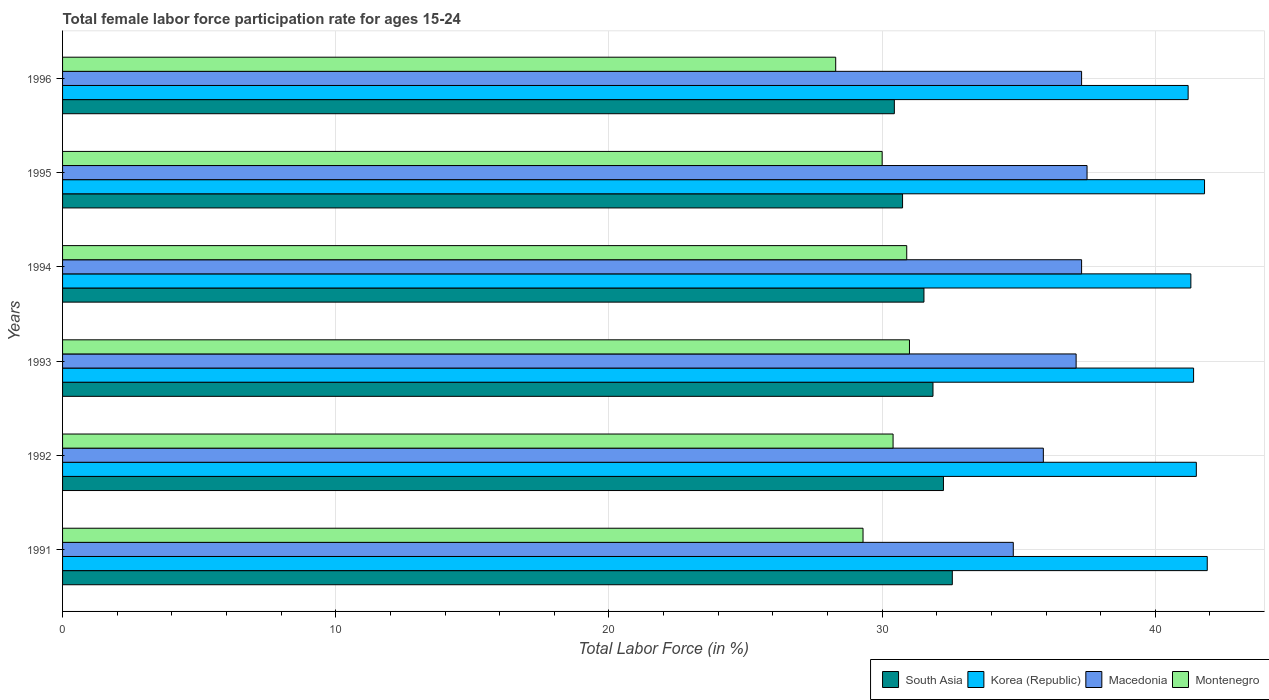How many groups of bars are there?
Offer a very short reply. 6. How many bars are there on the 5th tick from the bottom?
Your answer should be very brief. 4. In how many cases, is the number of bars for a given year not equal to the number of legend labels?
Your answer should be compact. 0. What is the female labor force participation rate in South Asia in 1993?
Give a very brief answer. 31.86. Across all years, what is the maximum female labor force participation rate in Montenegro?
Provide a short and direct response. 31. Across all years, what is the minimum female labor force participation rate in South Asia?
Make the answer very short. 30.45. In which year was the female labor force participation rate in Korea (Republic) maximum?
Make the answer very short. 1991. What is the total female labor force participation rate in South Asia in the graph?
Your response must be concise. 189.4. What is the difference between the female labor force participation rate in South Asia in 1994 and that in 1995?
Your answer should be very brief. 0.78. What is the difference between the female labor force participation rate in Korea (Republic) in 1996 and the female labor force participation rate in Montenegro in 1991?
Give a very brief answer. 11.9. What is the average female labor force participation rate in Macedonia per year?
Your response must be concise. 36.65. In the year 1994, what is the difference between the female labor force participation rate in Montenegro and female labor force participation rate in South Asia?
Your response must be concise. -0.63. What is the ratio of the female labor force participation rate in Macedonia in 1992 to that in 1996?
Ensure brevity in your answer.  0.96. Is the difference between the female labor force participation rate in Montenegro in 1995 and 1996 greater than the difference between the female labor force participation rate in South Asia in 1995 and 1996?
Give a very brief answer. Yes. What is the difference between the highest and the second highest female labor force participation rate in Montenegro?
Make the answer very short. 0.1. What is the difference between the highest and the lowest female labor force participation rate in Korea (Republic)?
Make the answer very short. 0.7. Is it the case that in every year, the sum of the female labor force participation rate in Macedonia and female labor force participation rate in Korea (Republic) is greater than the sum of female labor force participation rate in Montenegro and female labor force participation rate in South Asia?
Your response must be concise. Yes. What does the 1st bar from the top in 1996 represents?
Your answer should be compact. Montenegro. What does the 4th bar from the bottom in 1995 represents?
Your answer should be compact. Montenegro. How many years are there in the graph?
Your response must be concise. 6. What is the difference between two consecutive major ticks on the X-axis?
Provide a short and direct response. 10. Does the graph contain any zero values?
Offer a very short reply. No. Does the graph contain grids?
Your answer should be very brief. Yes. Where does the legend appear in the graph?
Offer a very short reply. Bottom right. How are the legend labels stacked?
Provide a short and direct response. Horizontal. What is the title of the graph?
Offer a very short reply. Total female labor force participation rate for ages 15-24. What is the label or title of the X-axis?
Your answer should be very brief. Total Labor Force (in %). What is the label or title of the Y-axis?
Provide a succinct answer. Years. What is the Total Labor Force (in %) of South Asia in 1991?
Make the answer very short. 32.57. What is the Total Labor Force (in %) in Korea (Republic) in 1991?
Your response must be concise. 41.9. What is the Total Labor Force (in %) in Macedonia in 1991?
Provide a short and direct response. 34.8. What is the Total Labor Force (in %) in Montenegro in 1991?
Offer a very short reply. 29.3. What is the Total Labor Force (in %) of South Asia in 1992?
Offer a terse response. 32.24. What is the Total Labor Force (in %) in Korea (Republic) in 1992?
Give a very brief answer. 41.5. What is the Total Labor Force (in %) in Macedonia in 1992?
Ensure brevity in your answer.  35.9. What is the Total Labor Force (in %) in Montenegro in 1992?
Your answer should be very brief. 30.4. What is the Total Labor Force (in %) of South Asia in 1993?
Offer a terse response. 31.86. What is the Total Labor Force (in %) in Korea (Republic) in 1993?
Your answer should be compact. 41.4. What is the Total Labor Force (in %) of Macedonia in 1993?
Offer a terse response. 37.1. What is the Total Labor Force (in %) of Montenegro in 1993?
Offer a terse response. 31. What is the Total Labor Force (in %) in South Asia in 1994?
Your answer should be very brief. 31.53. What is the Total Labor Force (in %) in Korea (Republic) in 1994?
Give a very brief answer. 41.3. What is the Total Labor Force (in %) in Macedonia in 1994?
Offer a very short reply. 37.3. What is the Total Labor Force (in %) of Montenegro in 1994?
Offer a terse response. 30.9. What is the Total Labor Force (in %) of South Asia in 1995?
Offer a terse response. 30.75. What is the Total Labor Force (in %) of Korea (Republic) in 1995?
Offer a terse response. 41.8. What is the Total Labor Force (in %) in Macedonia in 1995?
Provide a short and direct response. 37.5. What is the Total Labor Force (in %) in South Asia in 1996?
Give a very brief answer. 30.45. What is the Total Labor Force (in %) in Korea (Republic) in 1996?
Make the answer very short. 41.2. What is the Total Labor Force (in %) in Macedonia in 1996?
Your answer should be very brief. 37.3. What is the Total Labor Force (in %) of Montenegro in 1996?
Provide a short and direct response. 28.3. Across all years, what is the maximum Total Labor Force (in %) of South Asia?
Your response must be concise. 32.57. Across all years, what is the maximum Total Labor Force (in %) in Korea (Republic)?
Make the answer very short. 41.9. Across all years, what is the maximum Total Labor Force (in %) of Macedonia?
Provide a short and direct response. 37.5. Across all years, what is the maximum Total Labor Force (in %) in Montenegro?
Offer a very short reply. 31. Across all years, what is the minimum Total Labor Force (in %) of South Asia?
Your response must be concise. 30.45. Across all years, what is the minimum Total Labor Force (in %) of Korea (Republic)?
Offer a terse response. 41.2. Across all years, what is the minimum Total Labor Force (in %) of Macedonia?
Offer a very short reply. 34.8. Across all years, what is the minimum Total Labor Force (in %) in Montenegro?
Your answer should be compact. 28.3. What is the total Total Labor Force (in %) in South Asia in the graph?
Your answer should be compact. 189.4. What is the total Total Labor Force (in %) of Korea (Republic) in the graph?
Your answer should be very brief. 249.1. What is the total Total Labor Force (in %) in Macedonia in the graph?
Provide a short and direct response. 219.9. What is the total Total Labor Force (in %) of Montenegro in the graph?
Give a very brief answer. 179.9. What is the difference between the Total Labor Force (in %) in South Asia in 1991 and that in 1992?
Your response must be concise. 0.32. What is the difference between the Total Labor Force (in %) in Korea (Republic) in 1991 and that in 1992?
Ensure brevity in your answer.  0.4. What is the difference between the Total Labor Force (in %) in South Asia in 1991 and that in 1993?
Offer a very short reply. 0.71. What is the difference between the Total Labor Force (in %) in South Asia in 1991 and that in 1994?
Offer a very short reply. 1.04. What is the difference between the Total Labor Force (in %) in Macedonia in 1991 and that in 1994?
Keep it short and to the point. -2.5. What is the difference between the Total Labor Force (in %) of South Asia in 1991 and that in 1995?
Your response must be concise. 1.82. What is the difference between the Total Labor Force (in %) in Korea (Republic) in 1991 and that in 1995?
Your response must be concise. 0.1. What is the difference between the Total Labor Force (in %) of Macedonia in 1991 and that in 1995?
Your answer should be very brief. -2.7. What is the difference between the Total Labor Force (in %) of Montenegro in 1991 and that in 1995?
Give a very brief answer. -0.7. What is the difference between the Total Labor Force (in %) in South Asia in 1991 and that in 1996?
Provide a succinct answer. 2.12. What is the difference between the Total Labor Force (in %) of Korea (Republic) in 1991 and that in 1996?
Your answer should be compact. 0.7. What is the difference between the Total Labor Force (in %) of Montenegro in 1991 and that in 1996?
Provide a short and direct response. 1. What is the difference between the Total Labor Force (in %) of South Asia in 1992 and that in 1993?
Your answer should be compact. 0.38. What is the difference between the Total Labor Force (in %) of Korea (Republic) in 1992 and that in 1993?
Provide a succinct answer. 0.1. What is the difference between the Total Labor Force (in %) of Montenegro in 1992 and that in 1993?
Make the answer very short. -0.6. What is the difference between the Total Labor Force (in %) of South Asia in 1992 and that in 1994?
Your response must be concise. 0.71. What is the difference between the Total Labor Force (in %) in Macedonia in 1992 and that in 1994?
Offer a terse response. -1.4. What is the difference between the Total Labor Force (in %) of Montenegro in 1992 and that in 1994?
Ensure brevity in your answer.  -0.5. What is the difference between the Total Labor Force (in %) of South Asia in 1992 and that in 1995?
Your response must be concise. 1.5. What is the difference between the Total Labor Force (in %) in Korea (Republic) in 1992 and that in 1995?
Your response must be concise. -0.3. What is the difference between the Total Labor Force (in %) of Montenegro in 1992 and that in 1995?
Make the answer very short. 0.4. What is the difference between the Total Labor Force (in %) in South Asia in 1992 and that in 1996?
Provide a succinct answer. 1.8. What is the difference between the Total Labor Force (in %) in Macedonia in 1992 and that in 1996?
Your response must be concise. -1.4. What is the difference between the Total Labor Force (in %) of South Asia in 1993 and that in 1994?
Your response must be concise. 0.33. What is the difference between the Total Labor Force (in %) in Macedonia in 1993 and that in 1994?
Keep it short and to the point. -0.2. What is the difference between the Total Labor Force (in %) of Montenegro in 1993 and that in 1994?
Give a very brief answer. 0.1. What is the difference between the Total Labor Force (in %) of South Asia in 1993 and that in 1995?
Provide a short and direct response. 1.11. What is the difference between the Total Labor Force (in %) of Korea (Republic) in 1993 and that in 1995?
Make the answer very short. -0.4. What is the difference between the Total Labor Force (in %) in Montenegro in 1993 and that in 1995?
Your answer should be compact. 1. What is the difference between the Total Labor Force (in %) of South Asia in 1993 and that in 1996?
Keep it short and to the point. 1.41. What is the difference between the Total Labor Force (in %) of South Asia in 1994 and that in 1995?
Your response must be concise. 0.78. What is the difference between the Total Labor Force (in %) of Korea (Republic) in 1994 and that in 1995?
Offer a terse response. -0.5. What is the difference between the Total Labor Force (in %) of Montenegro in 1994 and that in 1995?
Your response must be concise. 0.9. What is the difference between the Total Labor Force (in %) of South Asia in 1994 and that in 1996?
Your response must be concise. 1.08. What is the difference between the Total Labor Force (in %) of Macedonia in 1994 and that in 1996?
Your answer should be compact. 0. What is the difference between the Total Labor Force (in %) of South Asia in 1995 and that in 1996?
Your answer should be very brief. 0.3. What is the difference between the Total Labor Force (in %) in Korea (Republic) in 1995 and that in 1996?
Your response must be concise. 0.6. What is the difference between the Total Labor Force (in %) of Macedonia in 1995 and that in 1996?
Keep it short and to the point. 0.2. What is the difference between the Total Labor Force (in %) of Montenegro in 1995 and that in 1996?
Ensure brevity in your answer.  1.7. What is the difference between the Total Labor Force (in %) of South Asia in 1991 and the Total Labor Force (in %) of Korea (Republic) in 1992?
Keep it short and to the point. -8.93. What is the difference between the Total Labor Force (in %) in South Asia in 1991 and the Total Labor Force (in %) in Macedonia in 1992?
Offer a very short reply. -3.33. What is the difference between the Total Labor Force (in %) in South Asia in 1991 and the Total Labor Force (in %) in Montenegro in 1992?
Offer a very short reply. 2.17. What is the difference between the Total Labor Force (in %) in Korea (Republic) in 1991 and the Total Labor Force (in %) in Macedonia in 1992?
Offer a very short reply. 6. What is the difference between the Total Labor Force (in %) of Korea (Republic) in 1991 and the Total Labor Force (in %) of Montenegro in 1992?
Offer a terse response. 11.5. What is the difference between the Total Labor Force (in %) in Macedonia in 1991 and the Total Labor Force (in %) in Montenegro in 1992?
Ensure brevity in your answer.  4.4. What is the difference between the Total Labor Force (in %) of South Asia in 1991 and the Total Labor Force (in %) of Korea (Republic) in 1993?
Your answer should be compact. -8.83. What is the difference between the Total Labor Force (in %) in South Asia in 1991 and the Total Labor Force (in %) in Macedonia in 1993?
Your answer should be very brief. -4.53. What is the difference between the Total Labor Force (in %) in South Asia in 1991 and the Total Labor Force (in %) in Montenegro in 1993?
Make the answer very short. 1.57. What is the difference between the Total Labor Force (in %) of Korea (Republic) in 1991 and the Total Labor Force (in %) of Macedonia in 1993?
Provide a short and direct response. 4.8. What is the difference between the Total Labor Force (in %) in Korea (Republic) in 1991 and the Total Labor Force (in %) in Montenegro in 1993?
Ensure brevity in your answer.  10.9. What is the difference between the Total Labor Force (in %) in South Asia in 1991 and the Total Labor Force (in %) in Korea (Republic) in 1994?
Your answer should be compact. -8.73. What is the difference between the Total Labor Force (in %) of South Asia in 1991 and the Total Labor Force (in %) of Macedonia in 1994?
Provide a short and direct response. -4.73. What is the difference between the Total Labor Force (in %) in South Asia in 1991 and the Total Labor Force (in %) in Montenegro in 1994?
Provide a short and direct response. 1.67. What is the difference between the Total Labor Force (in %) in Korea (Republic) in 1991 and the Total Labor Force (in %) in Macedonia in 1994?
Give a very brief answer. 4.6. What is the difference between the Total Labor Force (in %) of South Asia in 1991 and the Total Labor Force (in %) of Korea (Republic) in 1995?
Give a very brief answer. -9.23. What is the difference between the Total Labor Force (in %) in South Asia in 1991 and the Total Labor Force (in %) in Macedonia in 1995?
Ensure brevity in your answer.  -4.93. What is the difference between the Total Labor Force (in %) of South Asia in 1991 and the Total Labor Force (in %) of Montenegro in 1995?
Provide a short and direct response. 2.57. What is the difference between the Total Labor Force (in %) of South Asia in 1991 and the Total Labor Force (in %) of Korea (Republic) in 1996?
Keep it short and to the point. -8.63. What is the difference between the Total Labor Force (in %) in South Asia in 1991 and the Total Labor Force (in %) in Macedonia in 1996?
Your answer should be very brief. -4.73. What is the difference between the Total Labor Force (in %) of South Asia in 1991 and the Total Labor Force (in %) of Montenegro in 1996?
Ensure brevity in your answer.  4.27. What is the difference between the Total Labor Force (in %) of Korea (Republic) in 1991 and the Total Labor Force (in %) of Macedonia in 1996?
Offer a terse response. 4.6. What is the difference between the Total Labor Force (in %) of Macedonia in 1991 and the Total Labor Force (in %) of Montenegro in 1996?
Provide a succinct answer. 6.5. What is the difference between the Total Labor Force (in %) in South Asia in 1992 and the Total Labor Force (in %) in Korea (Republic) in 1993?
Make the answer very short. -9.16. What is the difference between the Total Labor Force (in %) in South Asia in 1992 and the Total Labor Force (in %) in Macedonia in 1993?
Ensure brevity in your answer.  -4.86. What is the difference between the Total Labor Force (in %) of South Asia in 1992 and the Total Labor Force (in %) of Montenegro in 1993?
Your answer should be very brief. 1.24. What is the difference between the Total Labor Force (in %) in Korea (Republic) in 1992 and the Total Labor Force (in %) in Montenegro in 1993?
Make the answer very short. 10.5. What is the difference between the Total Labor Force (in %) of South Asia in 1992 and the Total Labor Force (in %) of Korea (Republic) in 1994?
Make the answer very short. -9.06. What is the difference between the Total Labor Force (in %) in South Asia in 1992 and the Total Labor Force (in %) in Macedonia in 1994?
Ensure brevity in your answer.  -5.06. What is the difference between the Total Labor Force (in %) of South Asia in 1992 and the Total Labor Force (in %) of Montenegro in 1994?
Offer a very short reply. 1.34. What is the difference between the Total Labor Force (in %) in Korea (Republic) in 1992 and the Total Labor Force (in %) in Macedonia in 1994?
Make the answer very short. 4.2. What is the difference between the Total Labor Force (in %) of South Asia in 1992 and the Total Labor Force (in %) of Korea (Republic) in 1995?
Keep it short and to the point. -9.56. What is the difference between the Total Labor Force (in %) of South Asia in 1992 and the Total Labor Force (in %) of Macedonia in 1995?
Keep it short and to the point. -5.26. What is the difference between the Total Labor Force (in %) in South Asia in 1992 and the Total Labor Force (in %) in Montenegro in 1995?
Provide a short and direct response. 2.24. What is the difference between the Total Labor Force (in %) of Macedonia in 1992 and the Total Labor Force (in %) of Montenegro in 1995?
Provide a short and direct response. 5.9. What is the difference between the Total Labor Force (in %) of South Asia in 1992 and the Total Labor Force (in %) of Korea (Republic) in 1996?
Keep it short and to the point. -8.96. What is the difference between the Total Labor Force (in %) in South Asia in 1992 and the Total Labor Force (in %) in Macedonia in 1996?
Offer a terse response. -5.06. What is the difference between the Total Labor Force (in %) of South Asia in 1992 and the Total Labor Force (in %) of Montenegro in 1996?
Keep it short and to the point. 3.94. What is the difference between the Total Labor Force (in %) in Korea (Republic) in 1992 and the Total Labor Force (in %) in Montenegro in 1996?
Your response must be concise. 13.2. What is the difference between the Total Labor Force (in %) in Macedonia in 1992 and the Total Labor Force (in %) in Montenegro in 1996?
Your answer should be compact. 7.6. What is the difference between the Total Labor Force (in %) in South Asia in 1993 and the Total Labor Force (in %) in Korea (Republic) in 1994?
Ensure brevity in your answer.  -9.44. What is the difference between the Total Labor Force (in %) in South Asia in 1993 and the Total Labor Force (in %) in Macedonia in 1994?
Give a very brief answer. -5.44. What is the difference between the Total Labor Force (in %) of South Asia in 1993 and the Total Labor Force (in %) of Montenegro in 1994?
Offer a very short reply. 0.96. What is the difference between the Total Labor Force (in %) in Korea (Republic) in 1993 and the Total Labor Force (in %) in Macedonia in 1994?
Ensure brevity in your answer.  4.1. What is the difference between the Total Labor Force (in %) of Korea (Republic) in 1993 and the Total Labor Force (in %) of Montenegro in 1994?
Your answer should be very brief. 10.5. What is the difference between the Total Labor Force (in %) of South Asia in 1993 and the Total Labor Force (in %) of Korea (Republic) in 1995?
Keep it short and to the point. -9.94. What is the difference between the Total Labor Force (in %) in South Asia in 1993 and the Total Labor Force (in %) in Macedonia in 1995?
Ensure brevity in your answer.  -5.64. What is the difference between the Total Labor Force (in %) of South Asia in 1993 and the Total Labor Force (in %) of Montenegro in 1995?
Give a very brief answer. 1.86. What is the difference between the Total Labor Force (in %) of Korea (Republic) in 1993 and the Total Labor Force (in %) of Macedonia in 1995?
Give a very brief answer. 3.9. What is the difference between the Total Labor Force (in %) of Korea (Republic) in 1993 and the Total Labor Force (in %) of Montenegro in 1995?
Give a very brief answer. 11.4. What is the difference between the Total Labor Force (in %) of South Asia in 1993 and the Total Labor Force (in %) of Korea (Republic) in 1996?
Keep it short and to the point. -9.34. What is the difference between the Total Labor Force (in %) of South Asia in 1993 and the Total Labor Force (in %) of Macedonia in 1996?
Provide a succinct answer. -5.44. What is the difference between the Total Labor Force (in %) in South Asia in 1993 and the Total Labor Force (in %) in Montenegro in 1996?
Offer a very short reply. 3.56. What is the difference between the Total Labor Force (in %) in Korea (Republic) in 1993 and the Total Labor Force (in %) in Montenegro in 1996?
Your answer should be compact. 13.1. What is the difference between the Total Labor Force (in %) in Macedonia in 1993 and the Total Labor Force (in %) in Montenegro in 1996?
Keep it short and to the point. 8.8. What is the difference between the Total Labor Force (in %) of South Asia in 1994 and the Total Labor Force (in %) of Korea (Republic) in 1995?
Ensure brevity in your answer.  -10.27. What is the difference between the Total Labor Force (in %) of South Asia in 1994 and the Total Labor Force (in %) of Macedonia in 1995?
Your answer should be compact. -5.97. What is the difference between the Total Labor Force (in %) in South Asia in 1994 and the Total Labor Force (in %) in Montenegro in 1995?
Make the answer very short. 1.53. What is the difference between the Total Labor Force (in %) of Korea (Republic) in 1994 and the Total Labor Force (in %) of Macedonia in 1995?
Provide a short and direct response. 3.8. What is the difference between the Total Labor Force (in %) in South Asia in 1994 and the Total Labor Force (in %) in Korea (Republic) in 1996?
Offer a terse response. -9.67. What is the difference between the Total Labor Force (in %) of South Asia in 1994 and the Total Labor Force (in %) of Macedonia in 1996?
Give a very brief answer. -5.77. What is the difference between the Total Labor Force (in %) in South Asia in 1994 and the Total Labor Force (in %) in Montenegro in 1996?
Ensure brevity in your answer.  3.23. What is the difference between the Total Labor Force (in %) of South Asia in 1995 and the Total Labor Force (in %) of Korea (Republic) in 1996?
Ensure brevity in your answer.  -10.45. What is the difference between the Total Labor Force (in %) in South Asia in 1995 and the Total Labor Force (in %) in Macedonia in 1996?
Offer a terse response. -6.55. What is the difference between the Total Labor Force (in %) in South Asia in 1995 and the Total Labor Force (in %) in Montenegro in 1996?
Offer a very short reply. 2.45. What is the difference between the Total Labor Force (in %) of Korea (Republic) in 1995 and the Total Labor Force (in %) of Macedonia in 1996?
Make the answer very short. 4.5. What is the difference between the Total Labor Force (in %) of Macedonia in 1995 and the Total Labor Force (in %) of Montenegro in 1996?
Keep it short and to the point. 9.2. What is the average Total Labor Force (in %) of South Asia per year?
Give a very brief answer. 31.57. What is the average Total Labor Force (in %) of Korea (Republic) per year?
Ensure brevity in your answer.  41.52. What is the average Total Labor Force (in %) in Macedonia per year?
Your answer should be compact. 36.65. What is the average Total Labor Force (in %) in Montenegro per year?
Make the answer very short. 29.98. In the year 1991, what is the difference between the Total Labor Force (in %) in South Asia and Total Labor Force (in %) in Korea (Republic)?
Provide a succinct answer. -9.33. In the year 1991, what is the difference between the Total Labor Force (in %) in South Asia and Total Labor Force (in %) in Macedonia?
Give a very brief answer. -2.23. In the year 1991, what is the difference between the Total Labor Force (in %) in South Asia and Total Labor Force (in %) in Montenegro?
Your response must be concise. 3.27. In the year 1991, what is the difference between the Total Labor Force (in %) in Korea (Republic) and Total Labor Force (in %) in Montenegro?
Keep it short and to the point. 12.6. In the year 1992, what is the difference between the Total Labor Force (in %) in South Asia and Total Labor Force (in %) in Korea (Republic)?
Make the answer very short. -9.26. In the year 1992, what is the difference between the Total Labor Force (in %) in South Asia and Total Labor Force (in %) in Macedonia?
Your response must be concise. -3.66. In the year 1992, what is the difference between the Total Labor Force (in %) in South Asia and Total Labor Force (in %) in Montenegro?
Keep it short and to the point. 1.84. In the year 1993, what is the difference between the Total Labor Force (in %) in South Asia and Total Labor Force (in %) in Korea (Republic)?
Keep it short and to the point. -9.54. In the year 1993, what is the difference between the Total Labor Force (in %) of South Asia and Total Labor Force (in %) of Macedonia?
Offer a very short reply. -5.24. In the year 1993, what is the difference between the Total Labor Force (in %) of South Asia and Total Labor Force (in %) of Montenegro?
Make the answer very short. 0.86. In the year 1993, what is the difference between the Total Labor Force (in %) in Korea (Republic) and Total Labor Force (in %) in Macedonia?
Provide a succinct answer. 4.3. In the year 1993, what is the difference between the Total Labor Force (in %) in Korea (Republic) and Total Labor Force (in %) in Montenegro?
Provide a short and direct response. 10.4. In the year 1993, what is the difference between the Total Labor Force (in %) in Macedonia and Total Labor Force (in %) in Montenegro?
Your answer should be compact. 6.1. In the year 1994, what is the difference between the Total Labor Force (in %) of South Asia and Total Labor Force (in %) of Korea (Republic)?
Provide a succinct answer. -9.77. In the year 1994, what is the difference between the Total Labor Force (in %) of South Asia and Total Labor Force (in %) of Macedonia?
Ensure brevity in your answer.  -5.77. In the year 1994, what is the difference between the Total Labor Force (in %) of South Asia and Total Labor Force (in %) of Montenegro?
Ensure brevity in your answer.  0.63. In the year 1994, what is the difference between the Total Labor Force (in %) of Korea (Republic) and Total Labor Force (in %) of Montenegro?
Your answer should be compact. 10.4. In the year 1995, what is the difference between the Total Labor Force (in %) in South Asia and Total Labor Force (in %) in Korea (Republic)?
Offer a terse response. -11.05. In the year 1995, what is the difference between the Total Labor Force (in %) of South Asia and Total Labor Force (in %) of Macedonia?
Make the answer very short. -6.75. In the year 1995, what is the difference between the Total Labor Force (in %) of South Asia and Total Labor Force (in %) of Montenegro?
Your answer should be very brief. 0.75. In the year 1995, what is the difference between the Total Labor Force (in %) of Korea (Republic) and Total Labor Force (in %) of Montenegro?
Your answer should be very brief. 11.8. In the year 1995, what is the difference between the Total Labor Force (in %) in Macedonia and Total Labor Force (in %) in Montenegro?
Provide a succinct answer. 7.5. In the year 1996, what is the difference between the Total Labor Force (in %) in South Asia and Total Labor Force (in %) in Korea (Republic)?
Offer a very short reply. -10.75. In the year 1996, what is the difference between the Total Labor Force (in %) of South Asia and Total Labor Force (in %) of Macedonia?
Your answer should be compact. -6.85. In the year 1996, what is the difference between the Total Labor Force (in %) in South Asia and Total Labor Force (in %) in Montenegro?
Offer a very short reply. 2.15. In the year 1996, what is the difference between the Total Labor Force (in %) in Korea (Republic) and Total Labor Force (in %) in Macedonia?
Provide a short and direct response. 3.9. What is the ratio of the Total Labor Force (in %) in Korea (Republic) in 1991 to that in 1992?
Offer a very short reply. 1.01. What is the ratio of the Total Labor Force (in %) in Macedonia in 1991 to that in 1992?
Offer a terse response. 0.97. What is the ratio of the Total Labor Force (in %) in Montenegro in 1991 to that in 1992?
Provide a succinct answer. 0.96. What is the ratio of the Total Labor Force (in %) of South Asia in 1991 to that in 1993?
Your response must be concise. 1.02. What is the ratio of the Total Labor Force (in %) of Korea (Republic) in 1991 to that in 1993?
Your answer should be compact. 1.01. What is the ratio of the Total Labor Force (in %) of Macedonia in 1991 to that in 1993?
Make the answer very short. 0.94. What is the ratio of the Total Labor Force (in %) of Montenegro in 1991 to that in 1993?
Keep it short and to the point. 0.95. What is the ratio of the Total Labor Force (in %) in South Asia in 1991 to that in 1994?
Make the answer very short. 1.03. What is the ratio of the Total Labor Force (in %) of Korea (Republic) in 1991 to that in 1994?
Keep it short and to the point. 1.01. What is the ratio of the Total Labor Force (in %) of Macedonia in 1991 to that in 1994?
Offer a very short reply. 0.93. What is the ratio of the Total Labor Force (in %) of Montenegro in 1991 to that in 1994?
Provide a short and direct response. 0.95. What is the ratio of the Total Labor Force (in %) of South Asia in 1991 to that in 1995?
Keep it short and to the point. 1.06. What is the ratio of the Total Labor Force (in %) in Macedonia in 1991 to that in 1995?
Offer a terse response. 0.93. What is the ratio of the Total Labor Force (in %) in Montenegro in 1991 to that in 1995?
Ensure brevity in your answer.  0.98. What is the ratio of the Total Labor Force (in %) in South Asia in 1991 to that in 1996?
Your answer should be very brief. 1.07. What is the ratio of the Total Labor Force (in %) of Macedonia in 1991 to that in 1996?
Your answer should be compact. 0.93. What is the ratio of the Total Labor Force (in %) of Montenegro in 1991 to that in 1996?
Your answer should be very brief. 1.04. What is the ratio of the Total Labor Force (in %) in South Asia in 1992 to that in 1993?
Your answer should be very brief. 1.01. What is the ratio of the Total Labor Force (in %) in Montenegro in 1992 to that in 1993?
Ensure brevity in your answer.  0.98. What is the ratio of the Total Labor Force (in %) in South Asia in 1992 to that in 1994?
Provide a succinct answer. 1.02. What is the ratio of the Total Labor Force (in %) of Korea (Republic) in 1992 to that in 1994?
Keep it short and to the point. 1. What is the ratio of the Total Labor Force (in %) of Macedonia in 1992 to that in 1994?
Make the answer very short. 0.96. What is the ratio of the Total Labor Force (in %) in Montenegro in 1992 to that in 1994?
Keep it short and to the point. 0.98. What is the ratio of the Total Labor Force (in %) in South Asia in 1992 to that in 1995?
Give a very brief answer. 1.05. What is the ratio of the Total Labor Force (in %) of Macedonia in 1992 to that in 1995?
Your answer should be very brief. 0.96. What is the ratio of the Total Labor Force (in %) in Montenegro in 1992 to that in 1995?
Ensure brevity in your answer.  1.01. What is the ratio of the Total Labor Force (in %) in South Asia in 1992 to that in 1996?
Your answer should be very brief. 1.06. What is the ratio of the Total Labor Force (in %) of Korea (Republic) in 1992 to that in 1996?
Make the answer very short. 1.01. What is the ratio of the Total Labor Force (in %) in Macedonia in 1992 to that in 1996?
Offer a terse response. 0.96. What is the ratio of the Total Labor Force (in %) of Montenegro in 1992 to that in 1996?
Your answer should be very brief. 1.07. What is the ratio of the Total Labor Force (in %) in South Asia in 1993 to that in 1994?
Give a very brief answer. 1.01. What is the ratio of the Total Labor Force (in %) of Macedonia in 1993 to that in 1994?
Give a very brief answer. 0.99. What is the ratio of the Total Labor Force (in %) of South Asia in 1993 to that in 1995?
Your response must be concise. 1.04. What is the ratio of the Total Labor Force (in %) of Korea (Republic) in 1993 to that in 1995?
Provide a succinct answer. 0.99. What is the ratio of the Total Labor Force (in %) of Macedonia in 1993 to that in 1995?
Offer a terse response. 0.99. What is the ratio of the Total Labor Force (in %) in Montenegro in 1993 to that in 1995?
Your response must be concise. 1.03. What is the ratio of the Total Labor Force (in %) of South Asia in 1993 to that in 1996?
Offer a terse response. 1.05. What is the ratio of the Total Labor Force (in %) of Korea (Republic) in 1993 to that in 1996?
Provide a short and direct response. 1. What is the ratio of the Total Labor Force (in %) in Montenegro in 1993 to that in 1996?
Make the answer very short. 1.1. What is the ratio of the Total Labor Force (in %) of South Asia in 1994 to that in 1995?
Provide a succinct answer. 1.03. What is the ratio of the Total Labor Force (in %) in Macedonia in 1994 to that in 1995?
Give a very brief answer. 0.99. What is the ratio of the Total Labor Force (in %) of Montenegro in 1994 to that in 1995?
Your answer should be very brief. 1.03. What is the ratio of the Total Labor Force (in %) in South Asia in 1994 to that in 1996?
Offer a very short reply. 1.04. What is the ratio of the Total Labor Force (in %) of Korea (Republic) in 1994 to that in 1996?
Your answer should be compact. 1. What is the ratio of the Total Labor Force (in %) in Montenegro in 1994 to that in 1996?
Your response must be concise. 1.09. What is the ratio of the Total Labor Force (in %) in South Asia in 1995 to that in 1996?
Give a very brief answer. 1.01. What is the ratio of the Total Labor Force (in %) of Korea (Republic) in 1995 to that in 1996?
Your answer should be very brief. 1.01. What is the ratio of the Total Labor Force (in %) in Macedonia in 1995 to that in 1996?
Give a very brief answer. 1.01. What is the ratio of the Total Labor Force (in %) in Montenegro in 1995 to that in 1996?
Offer a terse response. 1.06. What is the difference between the highest and the second highest Total Labor Force (in %) in South Asia?
Provide a short and direct response. 0.32. What is the difference between the highest and the second highest Total Labor Force (in %) in Macedonia?
Offer a terse response. 0.2. What is the difference between the highest and the second highest Total Labor Force (in %) of Montenegro?
Give a very brief answer. 0.1. What is the difference between the highest and the lowest Total Labor Force (in %) of South Asia?
Ensure brevity in your answer.  2.12. What is the difference between the highest and the lowest Total Labor Force (in %) of Korea (Republic)?
Provide a succinct answer. 0.7. 